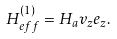<formula> <loc_0><loc_0><loc_500><loc_500>H _ { e f f } ^ { ( 1 ) } = H _ { a } v _ { z } e _ { z } .</formula> 